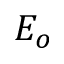<formula> <loc_0><loc_0><loc_500><loc_500>E _ { o }</formula> 